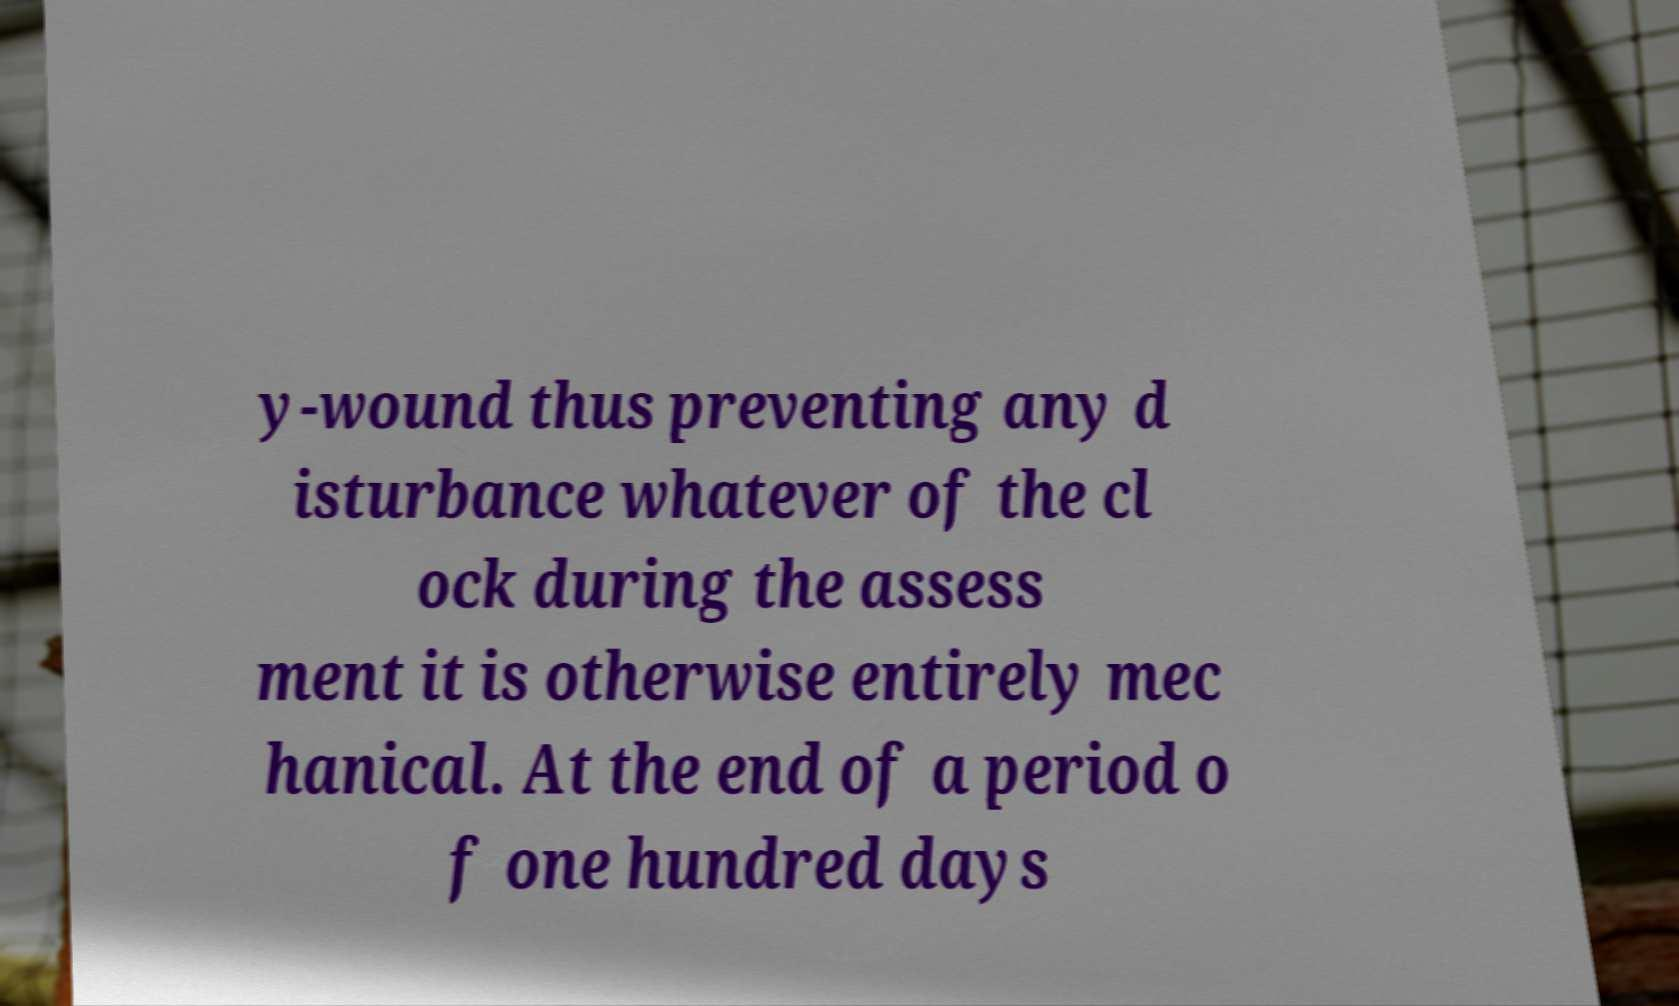I need the written content from this picture converted into text. Can you do that? y-wound thus preventing any d isturbance whatever of the cl ock during the assess ment it is otherwise entirely mec hanical. At the end of a period o f one hundred days 